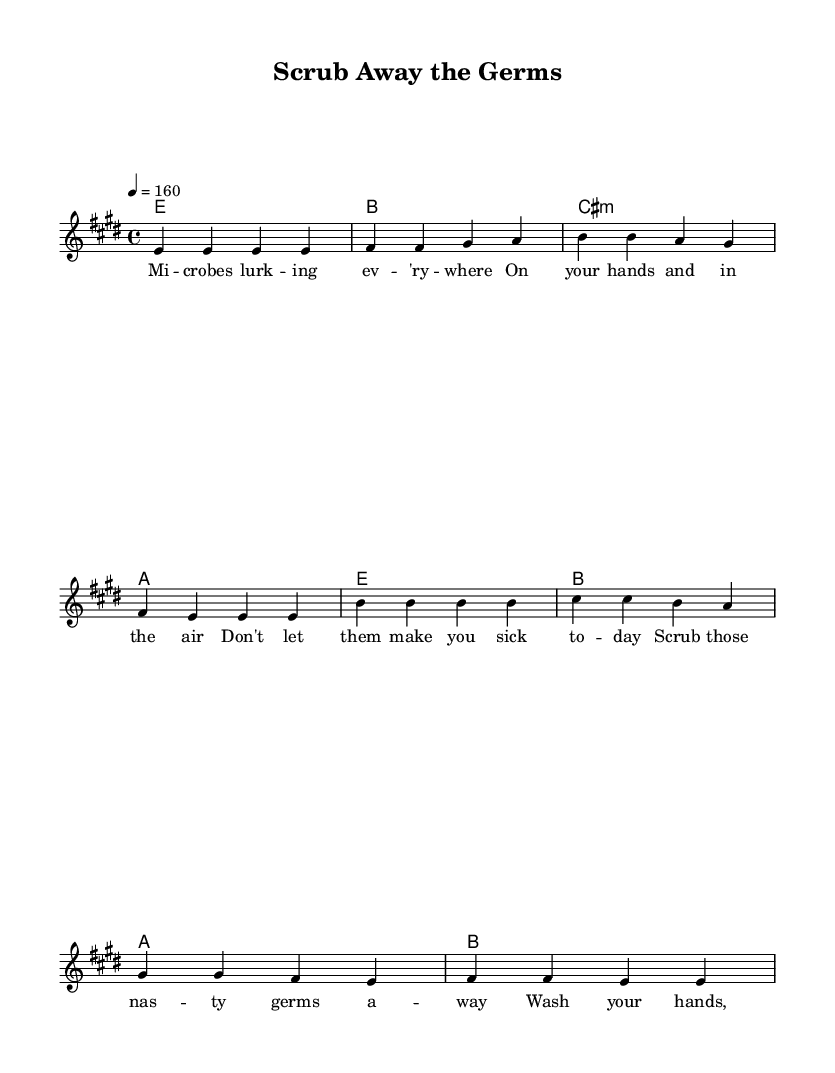What is the key signature of this music? The key signature shows two sharps, which indicates that the key is E major. In the key signature section, we look for the number of sharps or flats; here, there are two sharps (F# and C#).
Answer: E major What is the time signature of this music? The time signature is indicated at the beginning of the staff, where it shows the fraction 4/4. This means there are four beats in each measure and the quarter note gets one beat.
Answer: 4/4 What is the tempo marking for this piece? The tempo marking indicates the speed of the music and is found at the beginning. It reads "4 = 160," signifying that there are 160 quarter notes per minute.
Answer: 160 How many measures are there in the verse section? To find the number of measures in the verse section, we count the bars in the melodyVerse and lyrics under it. There are four bars in the verse, as represented by the four sequences of notes.
Answer: 4 What is the primary message of the lyrics in the chorus? In the chorus, the lyrics emphasize washing hands properly to combat unseen germs, which is a direct reminder of public health importance. The repetition and simple phrasing aid in memorization.
Answer: Wash your hands What chords accompany the chorus section? The chords for the chorus, as indicated in the harmonyChorus line, are E, B, A, and B. We can find these chords aligned with the melody in the composition.
Answer: E, B, A, B What characteristic of punk music is evident in the tempo? The tempo of 160 beats per minute is fast, which is characteristic of punk music, allowing for high energy and a sense of urgency in the message about hygiene.
Answer: Fast-paced 